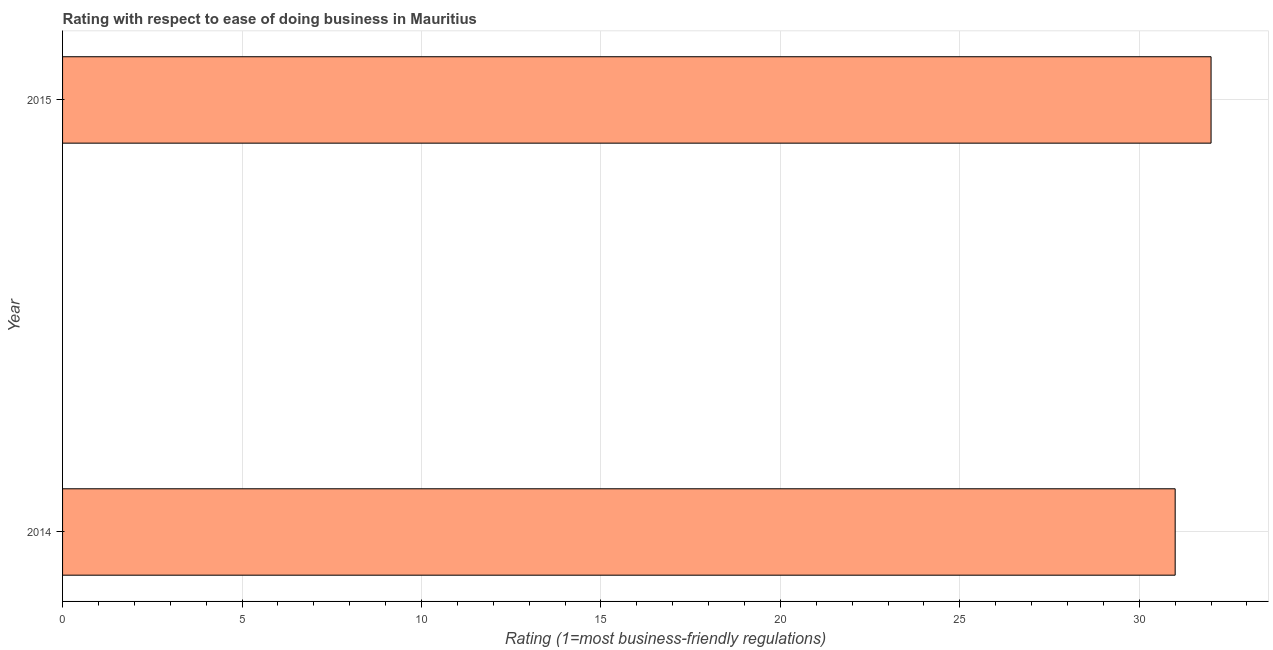Does the graph contain any zero values?
Make the answer very short. No. What is the title of the graph?
Make the answer very short. Rating with respect to ease of doing business in Mauritius. What is the label or title of the X-axis?
Provide a succinct answer. Rating (1=most business-friendly regulations). What is the label or title of the Y-axis?
Your answer should be very brief. Year. Across all years, what is the maximum ease of doing business index?
Give a very brief answer. 32. Across all years, what is the minimum ease of doing business index?
Provide a succinct answer. 31. In which year was the ease of doing business index maximum?
Provide a short and direct response. 2015. In which year was the ease of doing business index minimum?
Give a very brief answer. 2014. What is the sum of the ease of doing business index?
Your answer should be compact. 63. What is the average ease of doing business index per year?
Provide a short and direct response. 31. What is the median ease of doing business index?
Provide a short and direct response. 31.5. In how many years, is the ease of doing business index greater than 1 ?
Offer a very short reply. 2. Do a majority of the years between 2015 and 2014 (inclusive) have ease of doing business index greater than 25 ?
Give a very brief answer. No. Is the ease of doing business index in 2014 less than that in 2015?
Your response must be concise. Yes. How many bars are there?
Give a very brief answer. 2. How many years are there in the graph?
Your answer should be compact. 2. What is the difference between two consecutive major ticks on the X-axis?
Provide a short and direct response. 5. What is the Rating (1=most business-friendly regulations) of 2014?
Provide a succinct answer. 31. What is the difference between the Rating (1=most business-friendly regulations) in 2014 and 2015?
Ensure brevity in your answer.  -1. What is the ratio of the Rating (1=most business-friendly regulations) in 2014 to that in 2015?
Ensure brevity in your answer.  0.97. 